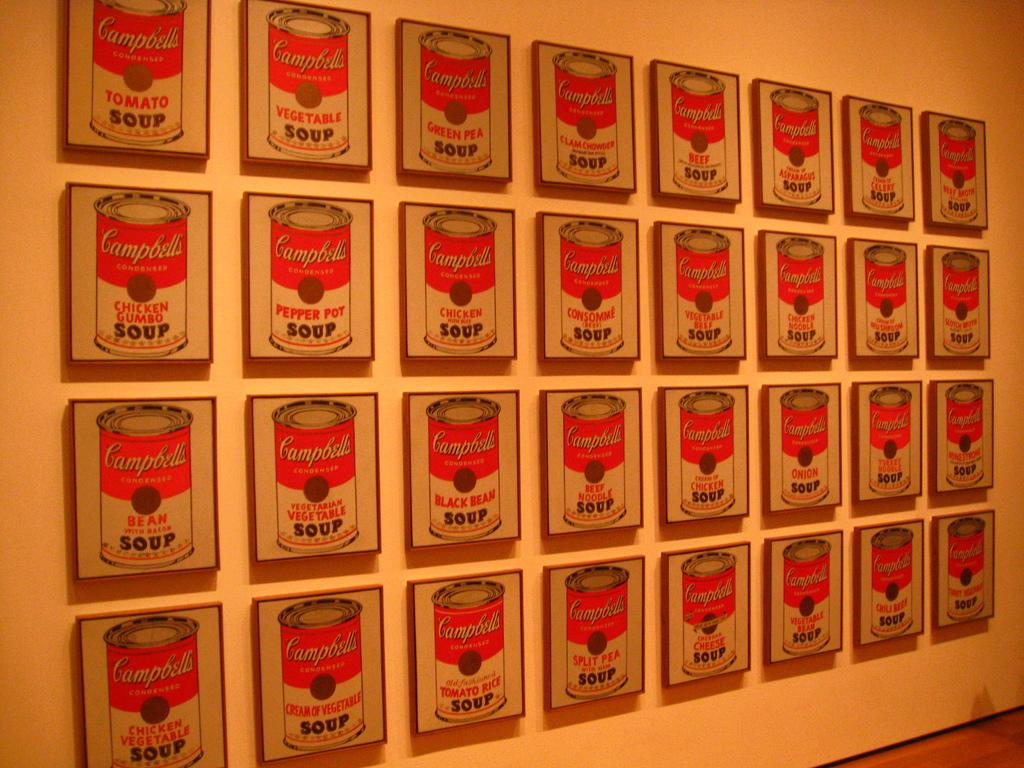Provide a one-sentence caption for the provided image. 32 images of different flavors of Campbell's Soup are displayed next to each other. 